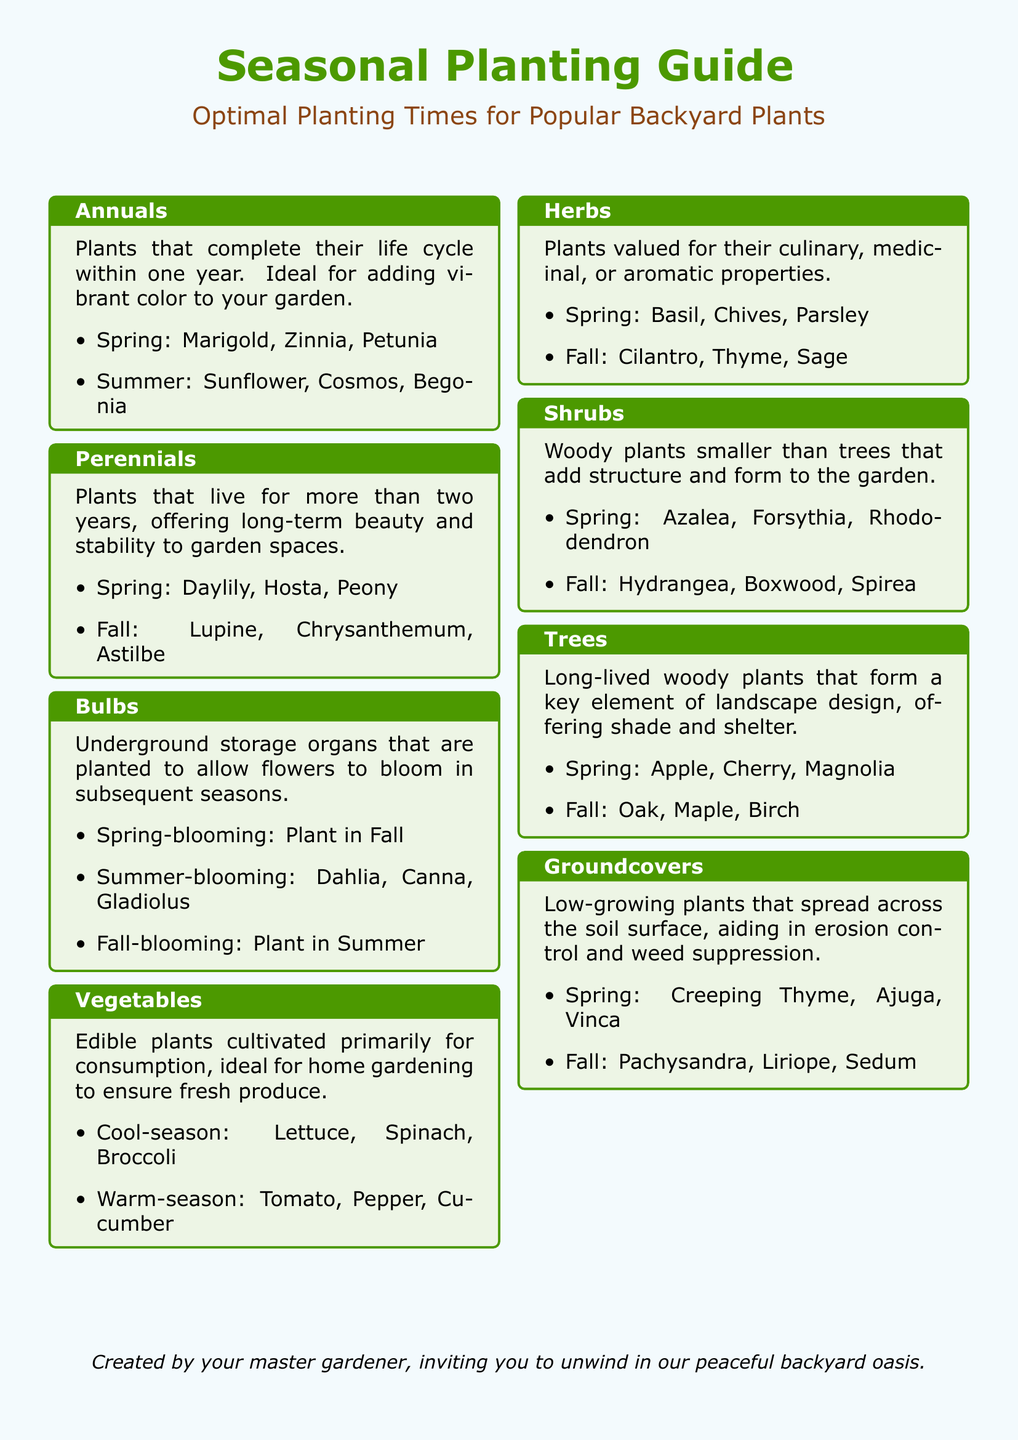What are annual plants? Annual plants are those that complete their life cycle within one year.
Answer: Complete their life cycle within one year When do you plant spring-blooming bulbs? Spring-blooming bulbs are planted in the fall according to the document.
Answer: In Fall Name a cool-season vegetable. The document lists lettuce as an example of a cool-season vegetable.
Answer: Lettuce What type of plants are designed to suppress weeds? Groundcovers are specifically mentioned as low-growing plants that help in weed suppression.
Answer: Groundcovers Which herb is recommended for planting in spring? The document includes basil as an herb to plant in spring.
Answer: Basil How long do perennials typically live? Perennials are described as plants that live for more than two years.
Answer: More than two years What is an example of a fall-blooming bulb? The document specifies dahlia as a summer-blooming bulb, not fall; therefore, the question can be formulated as looking for summer-blooming.
Answer: Dahlia What are shrubs used for in a garden? Shrubs are woody plants that add structure and form to the garden, according to the document.
Answer: Structure and form Which category includes apple trees? Apple trees fall under the category of trees, according to the planting guide.
Answer: Trees 